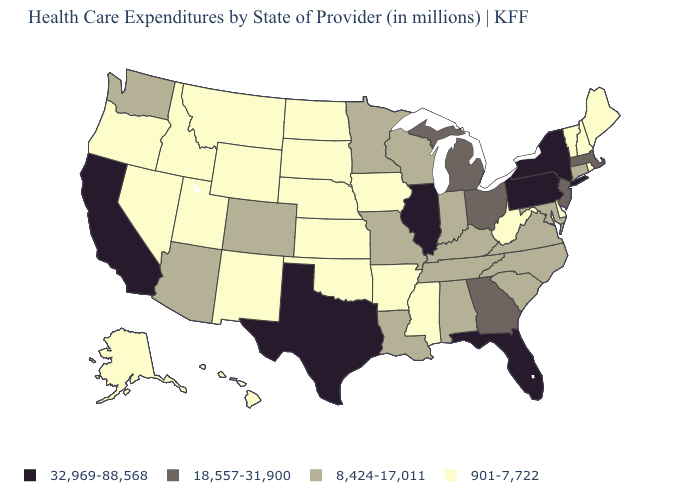Among the states that border Arkansas , does Mississippi have the highest value?
Quick response, please. No. Name the states that have a value in the range 901-7,722?
Write a very short answer. Alaska, Arkansas, Delaware, Hawaii, Idaho, Iowa, Kansas, Maine, Mississippi, Montana, Nebraska, Nevada, New Hampshire, New Mexico, North Dakota, Oklahoma, Oregon, Rhode Island, South Dakota, Utah, Vermont, West Virginia, Wyoming. What is the value of Rhode Island?
Give a very brief answer. 901-7,722. What is the value of Georgia?
Concise answer only. 18,557-31,900. Name the states that have a value in the range 8,424-17,011?
Give a very brief answer. Alabama, Arizona, Colorado, Connecticut, Indiana, Kentucky, Louisiana, Maryland, Minnesota, Missouri, North Carolina, South Carolina, Tennessee, Virginia, Washington, Wisconsin. Among the states that border New Jersey , which have the lowest value?
Quick response, please. Delaware. Does the map have missing data?
Give a very brief answer. No. Name the states that have a value in the range 32,969-88,568?
Be succinct. California, Florida, Illinois, New York, Pennsylvania, Texas. What is the value of Michigan?
Keep it brief. 18,557-31,900. What is the highest value in the USA?
Quick response, please. 32,969-88,568. Name the states that have a value in the range 18,557-31,900?
Give a very brief answer. Georgia, Massachusetts, Michigan, New Jersey, Ohio. Name the states that have a value in the range 901-7,722?
Give a very brief answer. Alaska, Arkansas, Delaware, Hawaii, Idaho, Iowa, Kansas, Maine, Mississippi, Montana, Nebraska, Nevada, New Hampshire, New Mexico, North Dakota, Oklahoma, Oregon, Rhode Island, South Dakota, Utah, Vermont, West Virginia, Wyoming. Name the states that have a value in the range 32,969-88,568?
Write a very short answer. California, Florida, Illinois, New York, Pennsylvania, Texas. Name the states that have a value in the range 901-7,722?
Write a very short answer. Alaska, Arkansas, Delaware, Hawaii, Idaho, Iowa, Kansas, Maine, Mississippi, Montana, Nebraska, Nevada, New Hampshire, New Mexico, North Dakota, Oklahoma, Oregon, Rhode Island, South Dakota, Utah, Vermont, West Virginia, Wyoming. Does Indiana have a lower value than Nevada?
Give a very brief answer. No. 